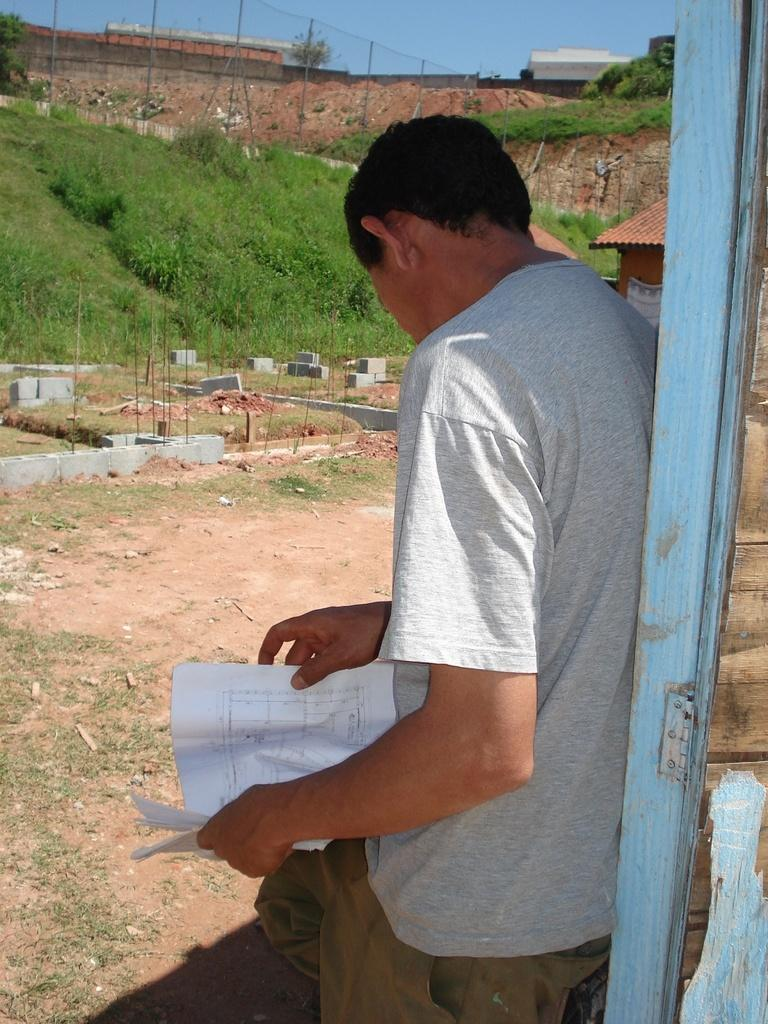What is the man in the image doing? The man is standing in the image. What is the man holding in his hand? The man is holding a paper in his hand. What type of door can be seen in the image? There is a wooden door in the image. What type of vegetation is present in the image? There are plants in the image. What architectural feature can be seen in the image? There is a fence in the image. What is the condition of the sky in the image? The sky is clear in the image. What type of eggnog is the man drinking in the image? There is no eggnog present in the image; the man is holding a paper in his hand. Can you see any yaks in the image? There are no yaks present in the image; the image features a man, a wooden door, plants, and a fence. 